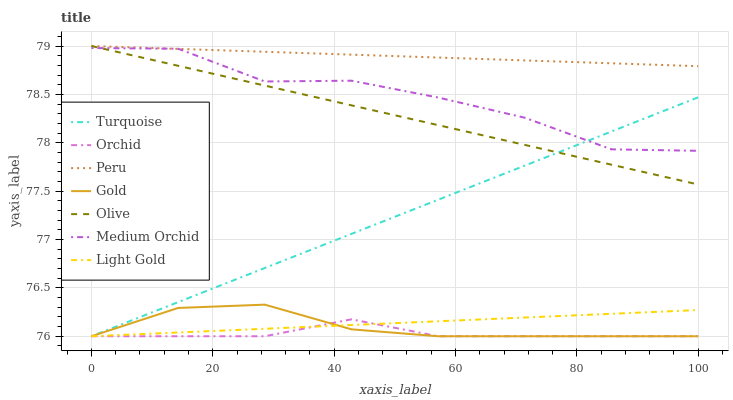Does Gold have the minimum area under the curve?
Answer yes or no. No. Does Gold have the maximum area under the curve?
Answer yes or no. No. Is Gold the smoothest?
Answer yes or no. No. Is Gold the roughest?
Answer yes or no. No. Does Medium Orchid have the lowest value?
Answer yes or no. No. Does Gold have the highest value?
Answer yes or no. No. Is Orchid less than Olive?
Answer yes or no. Yes. Is Olive greater than Gold?
Answer yes or no. Yes. Does Orchid intersect Olive?
Answer yes or no. No. 